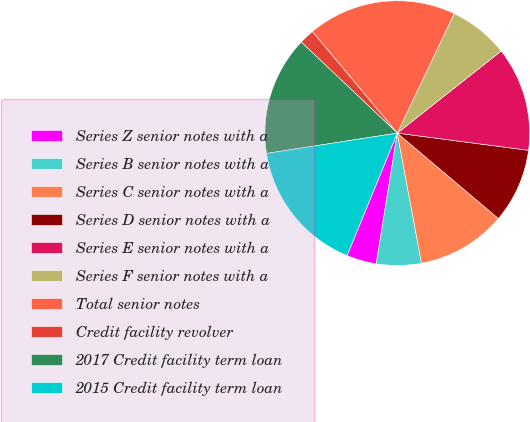Convert chart to OTSL. <chart><loc_0><loc_0><loc_500><loc_500><pie_chart><fcel>Series Z senior notes with a<fcel>Series B senior notes with a<fcel>Series C senior notes with a<fcel>Series D senior notes with a<fcel>Series E senior notes with a<fcel>Series F senior notes with a<fcel>Total senior notes<fcel>Credit facility revolver<fcel>2017 Credit facility term loan<fcel>2015 Credit facility term loan<nl><fcel>3.65%<fcel>5.47%<fcel>10.91%<fcel>9.09%<fcel>12.72%<fcel>7.28%<fcel>18.16%<fcel>1.84%<fcel>14.53%<fcel>16.35%<nl></chart> 